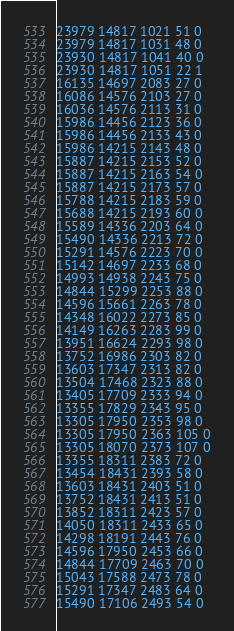Convert code to text. <code><loc_0><loc_0><loc_500><loc_500><_SML_>23979 14817 1021 51 0
23979 14817 1031 48 0
23930 14817 1041 40 0
23930 14817 1051 22 1
16135 14697 2083 27 0
16086 14576 2103 27 0
16036 14576 2113 31 0
15986 14456 2123 36 0
15986 14456 2133 43 0
15986 14215 2143 48 0
15887 14215 2153 52 0
15887 14215 2163 54 0
15887 14215 2173 57 0
15788 14215 2183 59 0
15688 14215 2193 60 0
15589 14336 2203 64 0
15490 14336 2213 72 0
15291 14576 2223 70 0
15142 14697 2233 68 0
14993 14938 2243 75 0
14844 15299 2253 88 0
14596 15661 2263 78 0
14348 16022 2273 85 0
14149 16263 2283 99 0
13951 16624 2293 98 0
13752 16986 2303 82 0
13603 17347 2313 82 0
13504 17468 2323 88 0
13405 17709 2333 94 0
13355 17829 2343 95 0
13305 17950 2353 98 0
13305 17950 2363 105 0
13305 18070 2373 107 0
13355 18311 2383 72 0
13454 18431 2393 58 0
13603 18431 2403 51 0
13752 18431 2413 51 0
13852 18311 2423 57 0
14050 18311 2433 65 0
14298 18191 2443 76 0
14596 17950 2453 66 0
14844 17709 2463 70 0
15043 17588 2473 78 0
15291 17347 2483 64 0
15490 17106 2493 54 0</code> 